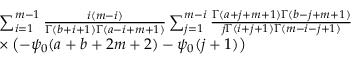<formula> <loc_0><loc_0><loc_500><loc_500>\begin{array} { r l } { \, } & { \sum _ { i = 1 } ^ { m - 1 } \frac { i ( m - i ) } { \Gamma ( b + i + 1 ) \Gamma ( a - i + m + 1 ) } \sum _ { j = 1 } ^ { m - i } \frac { \Gamma ( a + j + m + 1 ) \Gamma ( b - j + m + 1 ) } { j \Gamma ( i + j + 1 ) \Gamma ( m - i - j + 1 ) } } \\ { \, } & { \times \left ( - \psi _ { 0 } ( a + b + 2 m + 2 ) - \psi _ { 0 } ( j + 1 ) \right ) } \end{array}</formula> 